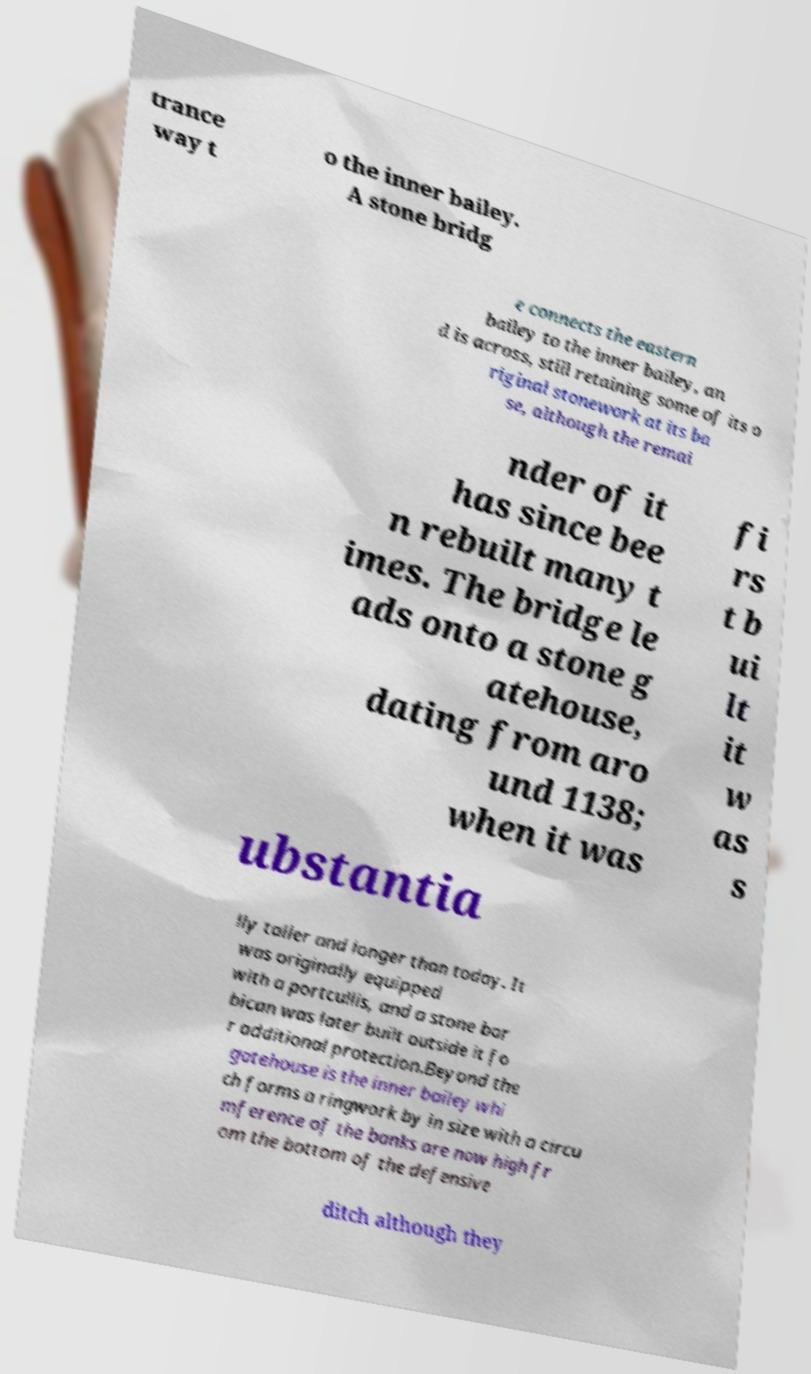Could you assist in decoding the text presented in this image and type it out clearly? trance way t o the inner bailey. A stone bridg e connects the eastern bailey to the inner bailey, an d is across, still retaining some of its o riginal stonework at its ba se, although the remai nder of it has since bee n rebuilt many t imes. The bridge le ads onto a stone g atehouse, dating from aro und 1138; when it was fi rs t b ui lt it w as s ubstantia lly taller and longer than today. It was originally equipped with a portcullis, and a stone bar bican was later built outside it fo r additional protection.Beyond the gatehouse is the inner bailey whi ch forms a ringwork by in size with a circu mference of the banks are now high fr om the bottom of the defensive ditch although they 